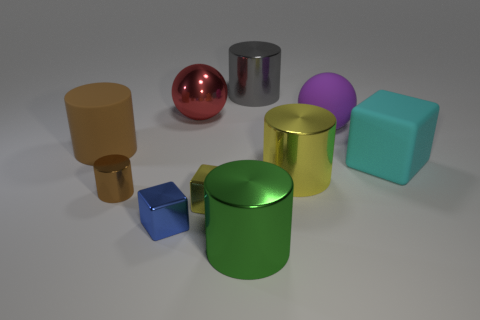There is a brown matte thing; is its shape the same as the big thing in front of the yellow cylinder?
Give a very brief answer. Yes. What shape is the small thing that is the same color as the matte cylinder?
Keep it short and to the point. Cylinder. Are there any cylinders that have the same material as the cyan thing?
Your answer should be compact. Yes. Is there anything else that has the same material as the large yellow object?
Your answer should be compact. Yes. What material is the sphere to the right of the sphere behind the purple object?
Provide a short and direct response. Rubber. What size is the yellow metallic thing behind the small yellow shiny block that is in front of the cylinder that is behind the large red metal sphere?
Your answer should be compact. Large. How many other objects are there of the same shape as the big yellow shiny thing?
Provide a short and direct response. 4. Does the big shiny cylinder that is behind the big purple rubber thing have the same color as the block to the right of the big gray thing?
Make the answer very short. No. What color is the cube that is the same size as the yellow metallic cylinder?
Offer a very short reply. Cyan. Is there a thing that has the same color as the metallic sphere?
Your response must be concise. No. 